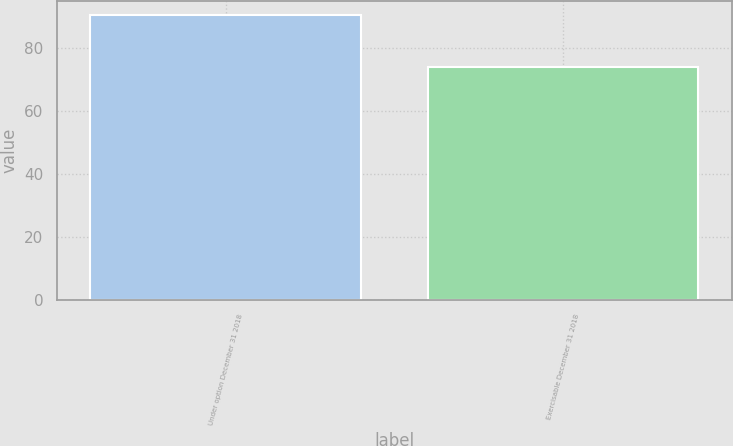<chart> <loc_0><loc_0><loc_500><loc_500><bar_chart><fcel>Under option December 31 2018<fcel>Exercisable December 31 2018<nl><fcel>90.56<fcel>74.08<nl></chart> 